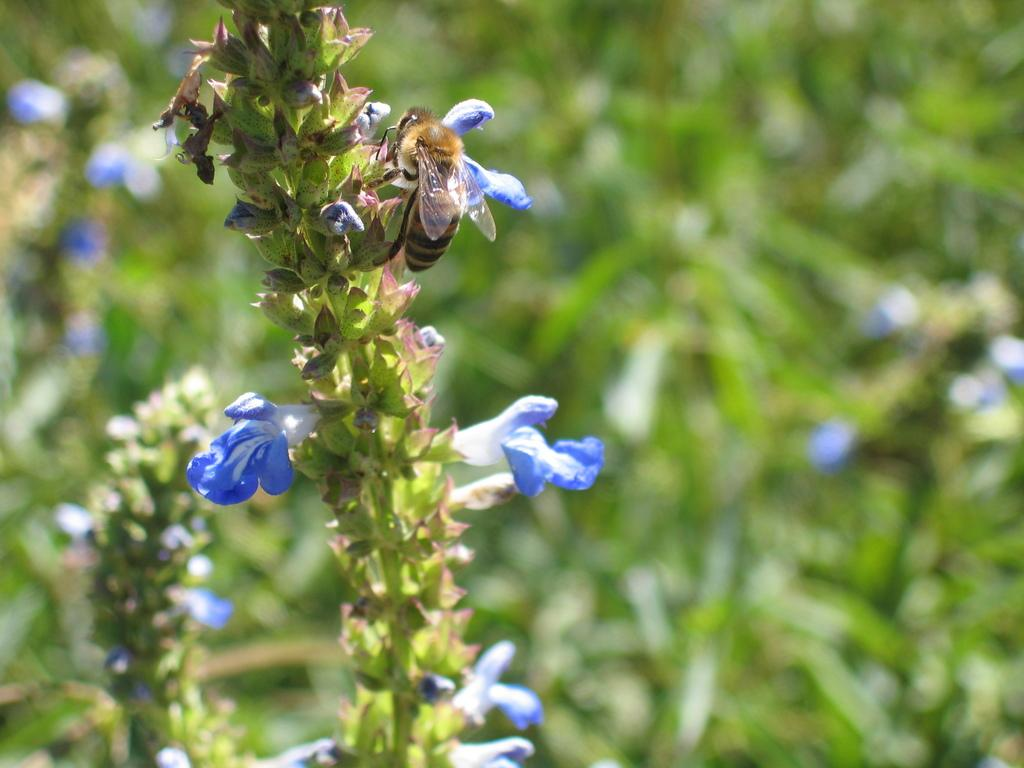What type of insect is present in the image? There is a bee in the image. Where is the bee located in the image? The bee is on a plant. What type of protest is happening in the image? There is no protest present in the image; it features a bee on a plant. Where are the ducks located in the image? There are no ducks present in the image. 